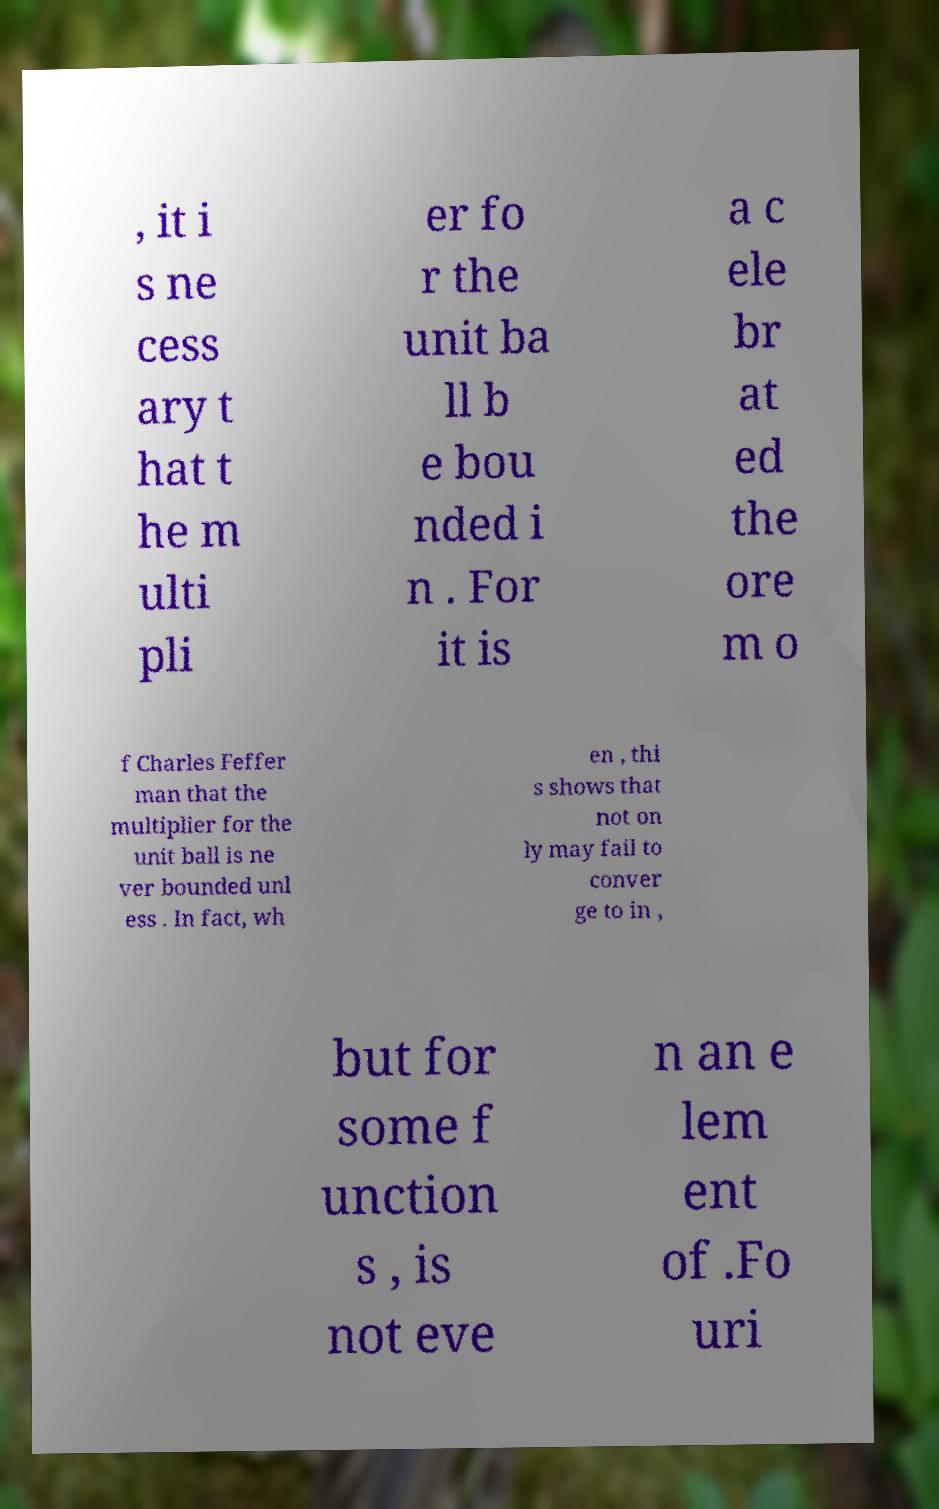Can you accurately transcribe the text from the provided image for me? , it i s ne cess ary t hat t he m ulti pli er fo r the unit ba ll b e bou nded i n . For it is a c ele br at ed the ore m o f Charles Feffer man that the multiplier for the unit ball is ne ver bounded unl ess . In fact, wh en , thi s shows that not on ly may fail to conver ge to in , but for some f unction s , is not eve n an e lem ent of .Fo uri 